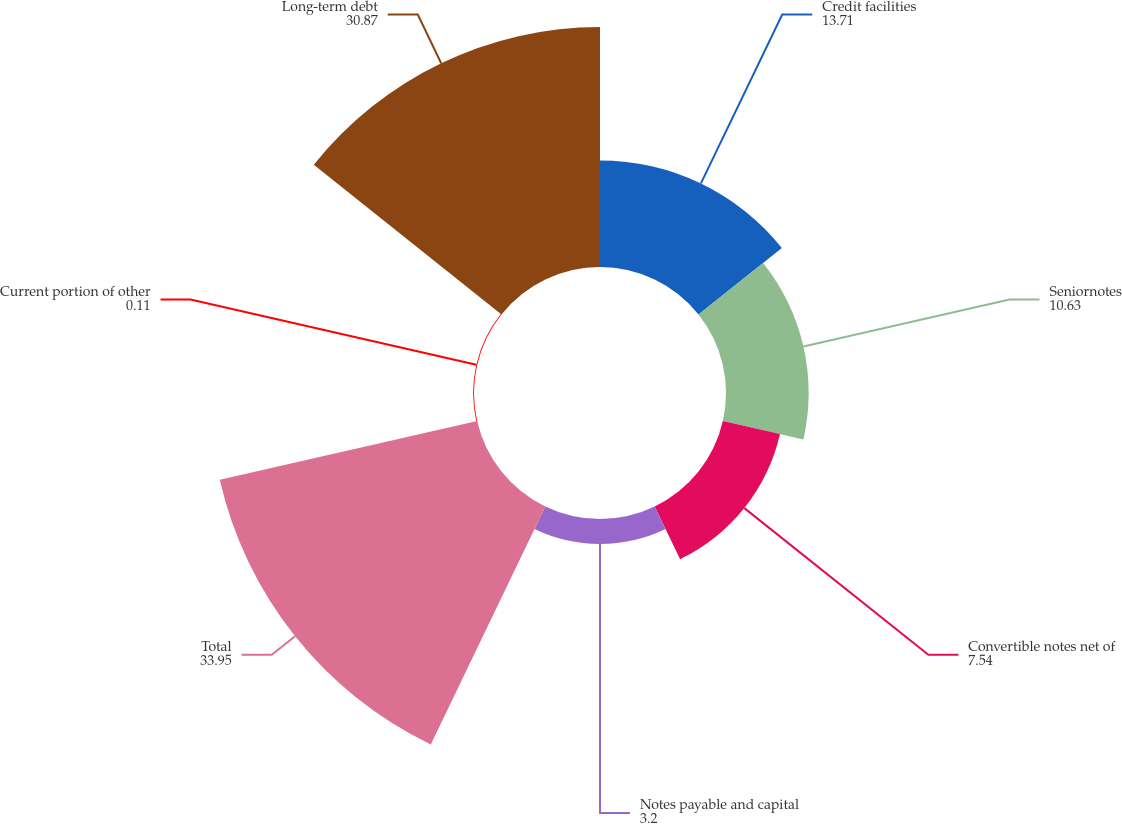Convert chart to OTSL. <chart><loc_0><loc_0><loc_500><loc_500><pie_chart><fcel>Credit facilities<fcel>Seniornotes<fcel>Convertible notes net of<fcel>Notes payable and capital<fcel>Total<fcel>Current portion of other<fcel>Long-term debt<nl><fcel>13.71%<fcel>10.63%<fcel>7.54%<fcel>3.2%<fcel>33.95%<fcel>0.11%<fcel>30.87%<nl></chart> 